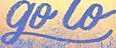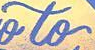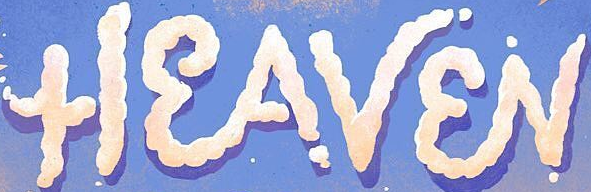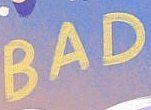Transcribe the words shown in these images in order, separated by a semicolon. go; to; HEAVEN; BAD 